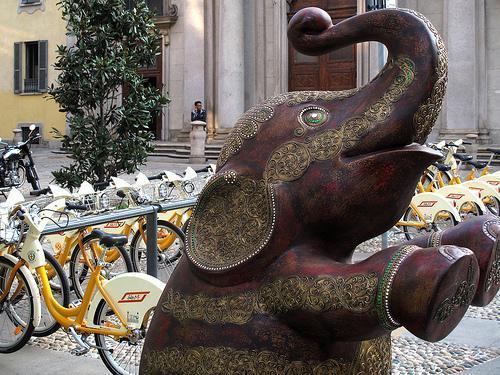How many people are in the picture?
Give a very brief answer. 1. How many trees are there?
Give a very brief answer. 1. How many elephants do you see?
Give a very brief answer. 1. 